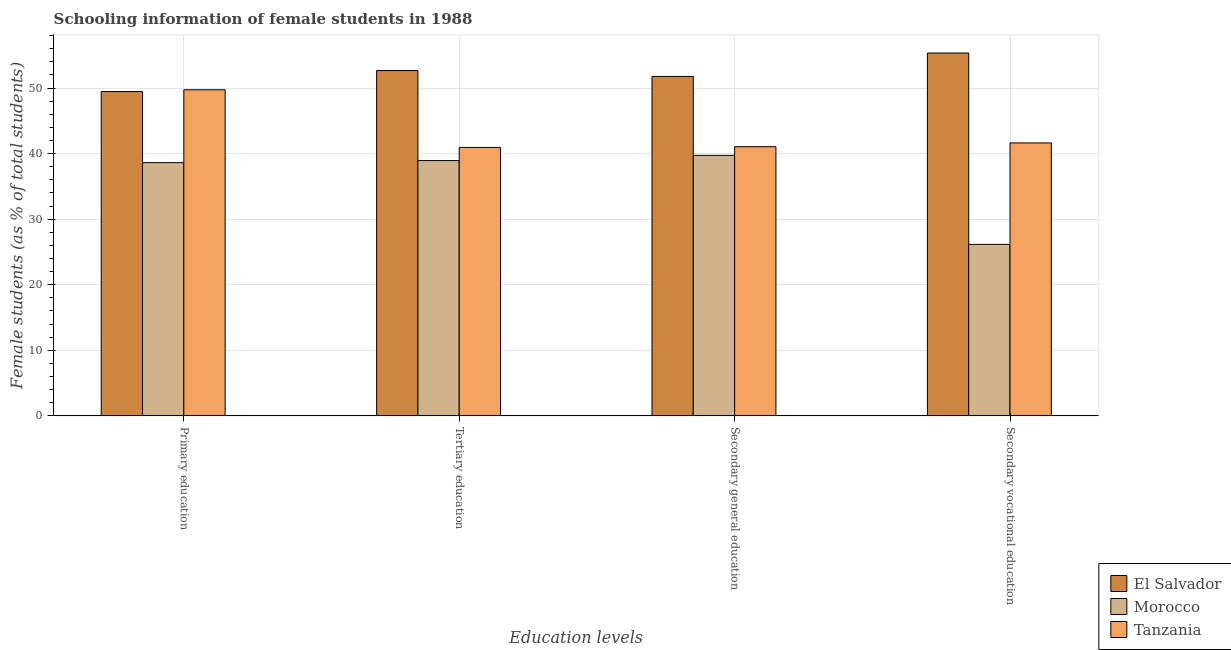How many groups of bars are there?
Give a very brief answer. 4. Are the number of bars on each tick of the X-axis equal?
Offer a terse response. Yes. How many bars are there on the 1st tick from the left?
Provide a short and direct response. 3. How many bars are there on the 2nd tick from the right?
Provide a short and direct response. 3. What is the label of the 1st group of bars from the left?
Your response must be concise. Primary education. What is the percentage of female students in secondary vocational education in Tanzania?
Offer a terse response. 41.64. Across all countries, what is the maximum percentage of female students in secondary education?
Ensure brevity in your answer.  51.78. Across all countries, what is the minimum percentage of female students in secondary education?
Your response must be concise. 39.74. In which country was the percentage of female students in secondary vocational education maximum?
Keep it short and to the point. El Salvador. In which country was the percentage of female students in secondary vocational education minimum?
Offer a terse response. Morocco. What is the total percentage of female students in secondary education in the graph?
Your answer should be compact. 132.58. What is the difference between the percentage of female students in secondary education in Tanzania and that in Morocco?
Ensure brevity in your answer.  1.32. What is the difference between the percentage of female students in tertiary education in El Salvador and the percentage of female students in secondary education in Tanzania?
Your response must be concise. 11.62. What is the average percentage of female students in secondary vocational education per country?
Your response must be concise. 41.05. What is the difference between the percentage of female students in tertiary education and percentage of female students in secondary vocational education in Morocco?
Make the answer very short. 12.78. In how many countries, is the percentage of female students in tertiary education greater than 38 %?
Your answer should be compact. 3. What is the ratio of the percentage of female students in secondary education in El Salvador to that in Tanzania?
Your answer should be compact. 1.26. What is the difference between the highest and the second highest percentage of female students in tertiary education?
Your answer should be compact. 11.73. What is the difference between the highest and the lowest percentage of female students in secondary education?
Ensure brevity in your answer.  12.04. Is the sum of the percentage of female students in secondary education in El Salvador and Tanzania greater than the maximum percentage of female students in primary education across all countries?
Offer a very short reply. Yes. Is it the case that in every country, the sum of the percentage of female students in secondary education and percentage of female students in primary education is greater than the sum of percentage of female students in tertiary education and percentage of female students in secondary vocational education?
Give a very brief answer. No. What does the 2nd bar from the left in Secondary vocational education represents?
Make the answer very short. Morocco. What does the 1st bar from the right in Tertiary education represents?
Your answer should be very brief. Tanzania. Does the graph contain grids?
Offer a very short reply. Yes. How many legend labels are there?
Ensure brevity in your answer.  3. How are the legend labels stacked?
Offer a terse response. Vertical. What is the title of the graph?
Provide a succinct answer. Schooling information of female students in 1988. Does "St. Martin (French part)" appear as one of the legend labels in the graph?
Make the answer very short. No. What is the label or title of the X-axis?
Offer a terse response. Education levels. What is the label or title of the Y-axis?
Your answer should be very brief. Female students (as % of total students). What is the Female students (as % of total students) of El Salvador in Primary education?
Ensure brevity in your answer.  49.47. What is the Female students (as % of total students) of Morocco in Primary education?
Offer a very short reply. 38.63. What is the Female students (as % of total students) of Tanzania in Primary education?
Your response must be concise. 49.74. What is the Female students (as % of total students) in El Salvador in Tertiary education?
Give a very brief answer. 52.68. What is the Female students (as % of total students) of Morocco in Tertiary education?
Your response must be concise. 38.94. What is the Female students (as % of total students) of Tanzania in Tertiary education?
Your answer should be very brief. 40.95. What is the Female students (as % of total students) in El Salvador in Secondary general education?
Your response must be concise. 51.78. What is the Female students (as % of total students) of Morocco in Secondary general education?
Your answer should be compact. 39.74. What is the Female students (as % of total students) in Tanzania in Secondary general education?
Your answer should be very brief. 41.06. What is the Female students (as % of total students) of El Salvador in Secondary vocational education?
Provide a short and direct response. 55.35. What is the Female students (as % of total students) in Morocco in Secondary vocational education?
Offer a very short reply. 26.16. What is the Female students (as % of total students) in Tanzania in Secondary vocational education?
Offer a terse response. 41.64. Across all Education levels, what is the maximum Female students (as % of total students) of El Salvador?
Provide a short and direct response. 55.35. Across all Education levels, what is the maximum Female students (as % of total students) of Morocco?
Keep it short and to the point. 39.74. Across all Education levels, what is the maximum Female students (as % of total students) of Tanzania?
Offer a very short reply. 49.74. Across all Education levels, what is the minimum Female students (as % of total students) in El Salvador?
Your answer should be compact. 49.47. Across all Education levels, what is the minimum Female students (as % of total students) of Morocco?
Keep it short and to the point. 26.16. Across all Education levels, what is the minimum Female students (as % of total students) of Tanzania?
Your response must be concise. 40.95. What is the total Female students (as % of total students) of El Salvador in the graph?
Give a very brief answer. 209.28. What is the total Female students (as % of total students) of Morocco in the graph?
Offer a terse response. 143.46. What is the total Female students (as % of total students) in Tanzania in the graph?
Your answer should be very brief. 173.39. What is the difference between the Female students (as % of total students) in El Salvador in Primary education and that in Tertiary education?
Offer a very short reply. -3.2. What is the difference between the Female students (as % of total students) of Morocco in Primary education and that in Tertiary education?
Provide a succinct answer. -0.32. What is the difference between the Female students (as % of total students) of Tanzania in Primary education and that in Tertiary education?
Provide a short and direct response. 8.8. What is the difference between the Female students (as % of total students) of El Salvador in Primary education and that in Secondary general education?
Give a very brief answer. -2.31. What is the difference between the Female students (as % of total students) in Morocco in Primary education and that in Secondary general education?
Keep it short and to the point. -1.11. What is the difference between the Female students (as % of total students) in Tanzania in Primary education and that in Secondary general education?
Provide a succinct answer. 8.68. What is the difference between the Female students (as % of total students) of El Salvador in Primary education and that in Secondary vocational education?
Offer a terse response. -5.88. What is the difference between the Female students (as % of total students) in Morocco in Primary education and that in Secondary vocational education?
Give a very brief answer. 12.47. What is the difference between the Female students (as % of total students) of Tanzania in Primary education and that in Secondary vocational education?
Your answer should be very brief. 8.11. What is the difference between the Female students (as % of total students) of El Salvador in Tertiary education and that in Secondary general education?
Your response must be concise. 0.9. What is the difference between the Female students (as % of total students) of Morocco in Tertiary education and that in Secondary general education?
Provide a succinct answer. -0.8. What is the difference between the Female students (as % of total students) in Tanzania in Tertiary education and that in Secondary general education?
Keep it short and to the point. -0.11. What is the difference between the Female students (as % of total students) in El Salvador in Tertiary education and that in Secondary vocational education?
Give a very brief answer. -2.67. What is the difference between the Female students (as % of total students) of Morocco in Tertiary education and that in Secondary vocational education?
Your answer should be very brief. 12.78. What is the difference between the Female students (as % of total students) in Tanzania in Tertiary education and that in Secondary vocational education?
Ensure brevity in your answer.  -0.69. What is the difference between the Female students (as % of total students) in El Salvador in Secondary general education and that in Secondary vocational education?
Provide a short and direct response. -3.57. What is the difference between the Female students (as % of total students) of Morocco in Secondary general education and that in Secondary vocational education?
Your answer should be compact. 13.58. What is the difference between the Female students (as % of total students) of Tanzania in Secondary general education and that in Secondary vocational education?
Give a very brief answer. -0.58. What is the difference between the Female students (as % of total students) of El Salvador in Primary education and the Female students (as % of total students) of Morocco in Tertiary education?
Your answer should be compact. 10.53. What is the difference between the Female students (as % of total students) of El Salvador in Primary education and the Female students (as % of total students) of Tanzania in Tertiary education?
Your answer should be compact. 8.53. What is the difference between the Female students (as % of total students) in Morocco in Primary education and the Female students (as % of total students) in Tanzania in Tertiary education?
Offer a very short reply. -2.32. What is the difference between the Female students (as % of total students) of El Salvador in Primary education and the Female students (as % of total students) of Morocco in Secondary general education?
Offer a terse response. 9.73. What is the difference between the Female students (as % of total students) in El Salvador in Primary education and the Female students (as % of total students) in Tanzania in Secondary general education?
Ensure brevity in your answer.  8.41. What is the difference between the Female students (as % of total students) of Morocco in Primary education and the Female students (as % of total students) of Tanzania in Secondary general education?
Your response must be concise. -2.44. What is the difference between the Female students (as % of total students) in El Salvador in Primary education and the Female students (as % of total students) in Morocco in Secondary vocational education?
Your answer should be compact. 23.31. What is the difference between the Female students (as % of total students) in El Salvador in Primary education and the Female students (as % of total students) in Tanzania in Secondary vocational education?
Your answer should be very brief. 7.83. What is the difference between the Female students (as % of total students) in Morocco in Primary education and the Female students (as % of total students) in Tanzania in Secondary vocational education?
Make the answer very short. -3.01. What is the difference between the Female students (as % of total students) of El Salvador in Tertiary education and the Female students (as % of total students) of Morocco in Secondary general education?
Your answer should be very brief. 12.94. What is the difference between the Female students (as % of total students) in El Salvador in Tertiary education and the Female students (as % of total students) in Tanzania in Secondary general education?
Provide a succinct answer. 11.62. What is the difference between the Female students (as % of total students) in Morocco in Tertiary education and the Female students (as % of total students) in Tanzania in Secondary general education?
Give a very brief answer. -2.12. What is the difference between the Female students (as % of total students) in El Salvador in Tertiary education and the Female students (as % of total students) in Morocco in Secondary vocational education?
Provide a succinct answer. 26.52. What is the difference between the Female students (as % of total students) in El Salvador in Tertiary education and the Female students (as % of total students) in Tanzania in Secondary vocational education?
Ensure brevity in your answer.  11.04. What is the difference between the Female students (as % of total students) of Morocco in Tertiary education and the Female students (as % of total students) of Tanzania in Secondary vocational education?
Your answer should be very brief. -2.7. What is the difference between the Female students (as % of total students) of El Salvador in Secondary general education and the Female students (as % of total students) of Morocco in Secondary vocational education?
Offer a terse response. 25.62. What is the difference between the Female students (as % of total students) of El Salvador in Secondary general education and the Female students (as % of total students) of Tanzania in Secondary vocational education?
Offer a very short reply. 10.14. What is the difference between the Female students (as % of total students) of Morocco in Secondary general education and the Female students (as % of total students) of Tanzania in Secondary vocational education?
Give a very brief answer. -1.9. What is the average Female students (as % of total students) of El Salvador per Education levels?
Give a very brief answer. 52.32. What is the average Female students (as % of total students) of Morocco per Education levels?
Give a very brief answer. 35.87. What is the average Female students (as % of total students) of Tanzania per Education levels?
Offer a terse response. 43.35. What is the difference between the Female students (as % of total students) in El Salvador and Female students (as % of total students) in Morocco in Primary education?
Your response must be concise. 10.85. What is the difference between the Female students (as % of total students) of El Salvador and Female students (as % of total students) of Tanzania in Primary education?
Your response must be concise. -0.27. What is the difference between the Female students (as % of total students) of Morocco and Female students (as % of total students) of Tanzania in Primary education?
Provide a short and direct response. -11.12. What is the difference between the Female students (as % of total students) of El Salvador and Female students (as % of total students) of Morocco in Tertiary education?
Provide a short and direct response. 13.73. What is the difference between the Female students (as % of total students) in El Salvador and Female students (as % of total students) in Tanzania in Tertiary education?
Your answer should be compact. 11.73. What is the difference between the Female students (as % of total students) of Morocco and Female students (as % of total students) of Tanzania in Tertiary education?
Provide a short and direct response. -2.01. What is the difference between the Female students (as % of total students) of El Salvador and Female students (as % of total students) of Morocco in Secondary general education?
Your answer should be compact. 12.04. What is the difference between the Female students (as % of total students) in El Salvador and Female students (as % of total students) in Tanzania in Secondary general education?
Ensure brevity in your answer.  10.72. What is the difference between the Female students (as % of total students) in Morocco and Female students (as % of total students) in Tanzania in Secondary general education?
Your answer should be compact. -1.32. What is the difference between the Female students (as % of total students) of El Salvador and Female students (as % of total students) of Morocco in Secondary vocational education?
Your response must be concise. 29.19. What is the difference between the Female students (as % of total students) of El Salvador and Female students (as % of total students) of Tanzania in Secondary vocational education?
Offer a terse response. 13.71. What is the difference between the Female students (as % of total students) in Morocco and Female students (as % of total students) in Tanzania in Secondary vocational education?
Ensure brevity in your answer.  -15.48. What is the ratio of the Female students (as % of total students) in El Salvador in Primary education to that in Tertiary education?
Offer a very short reply. 0.94. What is the ratio of the Female students (as % of total students) of Tanzania in Primary education to that in Tertiary education?
Ensure brevity in your answer.  1.21. What is the ratio of the Female students (as % of total students) in El Salvador in Primary education to that in Secondary general education?
Keep it short and to the point. 0.96. What is the ratio of the Female students (as % of total students) of Tanzania in Primary education to that in Secondary general education?
Provide a succinct answer. 1.21. What is the ratio of the Female students (as % of total students) of El Salvador in Primary education to that in Secondary vocational education?
Give a very brief answer. 0.89. What is the ratio of the Female students (as % of total students) in Morocco in Primary education to that in Secondary vocational education?
Your answer should be very brief. 1.48. What is the ratio of the Female students (as % of total students) of Tanzania in Primary education to that in Secondary vocational education?
Offer a terse response. 1.19. What is the ratio of the Female students (as % of total students) in El Salvador in Tertiary education to that in Secondary general education?
Your answer should be very brief. 1.02. What is the ratio of the Female students (as % of total students) in Morocco in Tertiary education to that in Secondary general education?
Provide a short and direct response. 0.98. What is the ratio of the Female students (as % of total students) in Tanzania in Tertiary education to that in Secondary general education?
Offer a very short reply. 1. What is the ratio of the Female students (as % of total students) of El Salvador in Tertiary education to that in Secondary vocational education?
Your answer should be compact. 0.95. What is the ratio of the Female students (as % of total students) in Morocco in Tertiary education to that in Secondary vocational education?
Ensure brevity in your answer.  1.49. What is the ratio of the Female students (as % of total students) of Tanzania in Tertiary education to that in Secondary vocational education?
Give a very brief answer. 0.98. What is the ratio of the Female students (as % of total students) in El Salvador in Secondary general education to that in Secondary vocational education?
Your response must be concise. 0.94. What is the ratio of the Female students (as % of total students) in Morocco in Secondary general education to that in Secondary vocational education?
Offer a very short reply. 1.52. What is the ratio of the Female students (as % of total students) of Tanzania in Secondary general education to that in Secondary vocational education?
Offer a very short reply. 0.99. What is the difference between the highest and the second highest Female students (as % of total students) in El Salvador?
Your answer should be very brief. 2.67. What is the difference between the highest and the second highest Female students (as % of total students) of Morocco?
Make the answer very short. 0.8. What is the difference between the highest and the second highest Female students (as % of total students) of Tanzania?
Your answer should be compact. 8.11. What is the difference between the highest and the lowest Female students (as % of total students) in El Salvador?
Keep it short and to the point. 5.88. What is the difference between the highest and the lowest Female students (as % of total students) of Morocco?
Give a very brief answer. 13.58. What is the difference between the highest and the lowest Female students (as % of total students) of Tanzania?
Provide a succinct answer. 8.8. 